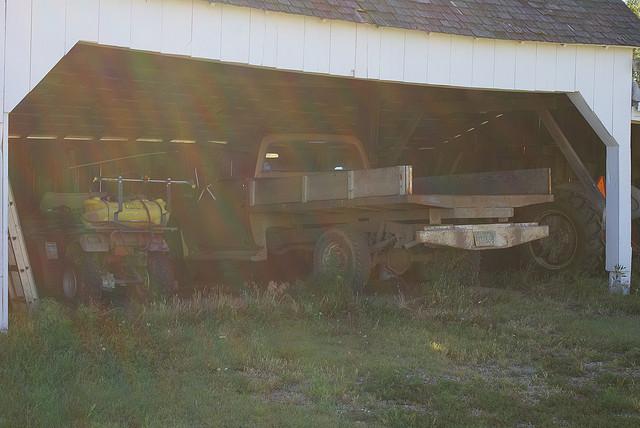Are they hiding the truck from the cops?
Quick response, please. No. What is next to the truck?
Write a very short answer. Tractor. What part of the train is this?
Keep it brief. None. Is there a fence?
Give a very brief answer. No. Does it seem that there is something grimy about this picture?
Short answer required. No. 